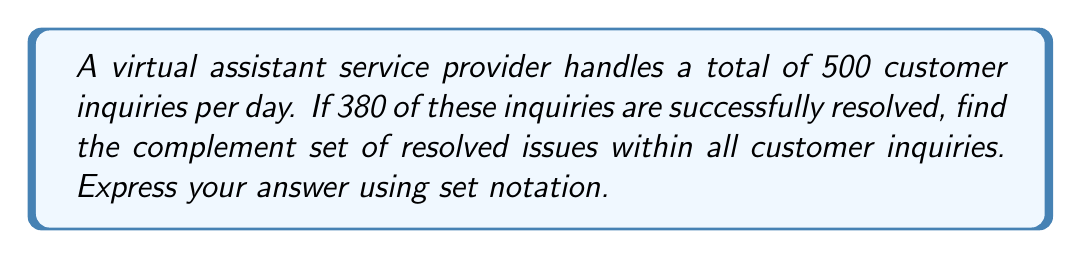Teach me how to tackle this problem. Let's approach this step-by-step:

1) First, let's define our universal set and subsets:
   Let $U$ be the set of all customer inquiries.
   Let $R$ be the set of resolved inquiries.

2) We know that:
   $|U| = 500$ (total number of inquiries)
   $|R| = 380$ (number of resolved inquiries)

3) The complement of set $R$, denoted as $R^c$, represents all elements in $U$ that are not in $R$. In this case, it's the set of unresolved inquiries.

4) To find the number of elements in $R^c$, we can use the formula:
   $|R^c| = |U| - |R|$

5) Substituting the values:
   $|R^c| = 500 - 380 = 120$

6) Therefore, there are 120 unresolved inquiries.

7) To express this using set notation, we can write:
   $R^c = \{x \in U : x \notin R\}$

This reads as "The set of all elements $x$ in $U$ such that $x$ is not in $R$."
Answer: $R^c = \{x \in U : x \notin R\}$, where $|R^c| = 120$ 